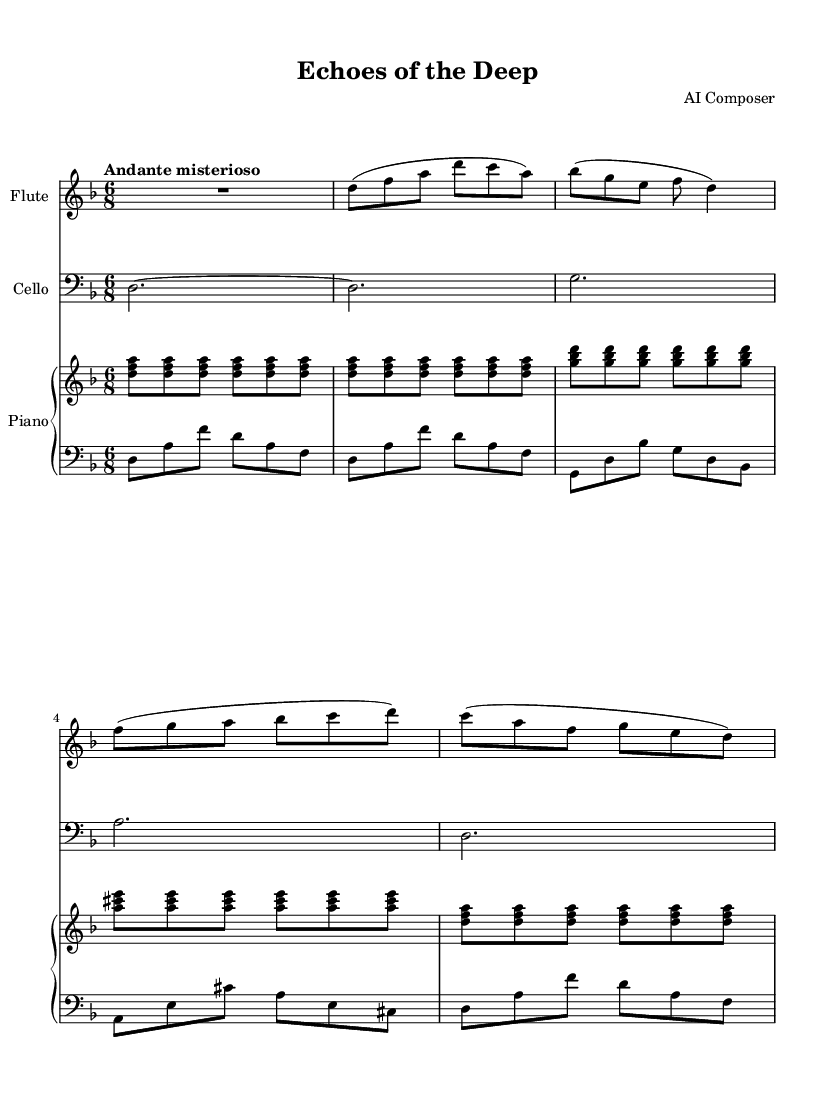What is the key signature of this music? The key signature is indicated by the sharps and flats at the beginning of the staff. In this case, there are no sharps or flats, which indicates it is in D minor.
Answer: D minor What is the time signature of this music? The time signature can be found at the beginning of the staff, shown as a fraction. Here, it is written as 6/8, indicating there are six eighth notes per measure.
Answer: 6/8 What is the tempo marking for this piece? The tempo marking is usually found at the beginning of the sheet music, describing how fast or slow the piece should be played. It is indicated as "Andante misterioso," which suggests a moderately slow tempo with a mysterious character.
Answer: Andante misterioso How many instruments are featured in this composition? By observing the score, the piece consists of three staves, indicating three separate instruments: flute, cello, and piano (which has separate upper and lower staves).
Answer: Three What dynamics are indicated for the flute part? Dynamics are often shown in the form of symbols or Italian terms placed above or below the staff. In the flute part, there isn't a specific dynamic marking, suggesting a softer or expressive play. Since the full sheet did not include dynamic notations, one assumes it's open to interpretation.
Answer: None specified Which instrument plays the lowest pitch in this composition? By comparing the ranges of the instruments in the score, the cello part, notated in the bass clef, is the lowest as it typically plays in a lower register than the flute or piano.
Answer: Cello Is there a recurring motif in the flute part? Examining the flute part reveals that certain note patterns appear more than once, suggesting a thematic recurrence. The phrase starting with the d note in the flute part is repeated in similar forms, evoking a sense of continuity.
Answer: Yes 